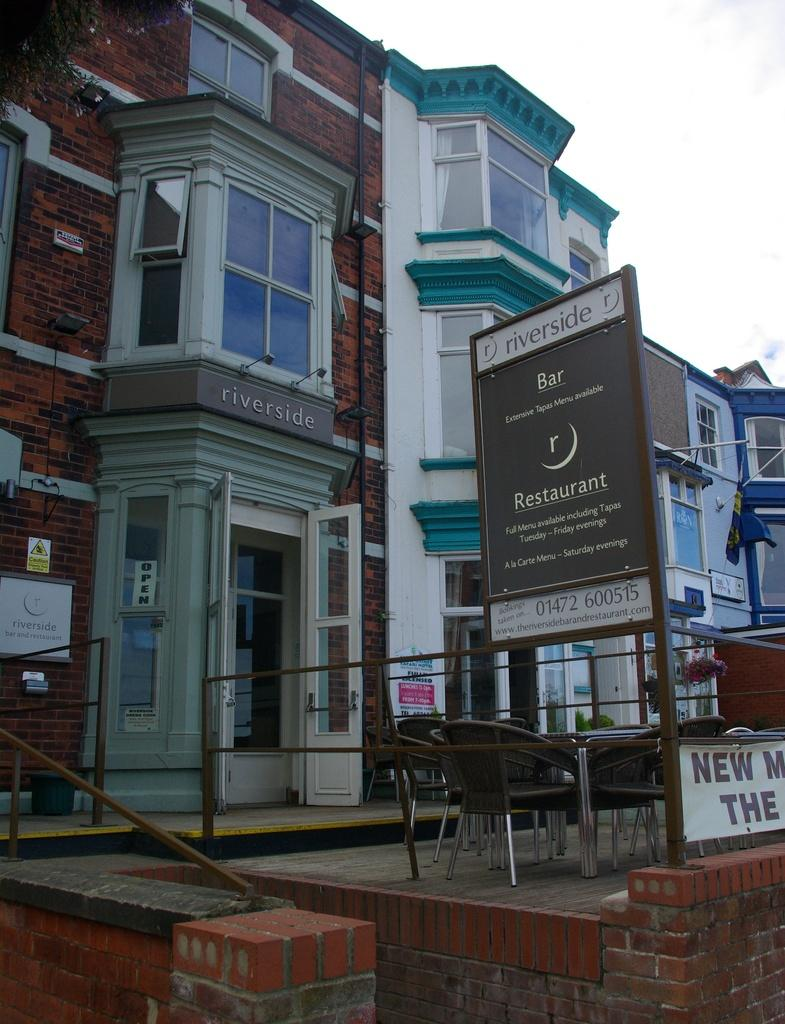What type of structures are visible in the image? There are buildings with windows in the image. What can be found on the boards in the image? There are boards with text in the image. What type of furniture is present in the image? There are chairs in the image. What material is used for the walls of the buildings in the image? There are brick walls in the image. What is visible in the background of the image? The sky is visible in the image. What type of cushion is used for breakfast in the image? There is no cushion or breakfast present in the image. How many bits can be seen on the brick walls in the image? There are no bits present on the brick walls in the image. 